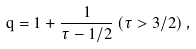<formula> <loc_0><loc_0><loc_500><loc_500>q = 1 + \frac { 1 } { \tau - 1 / 2 } \, ( \tau > 3 / 2 ) \, ,</formula> 